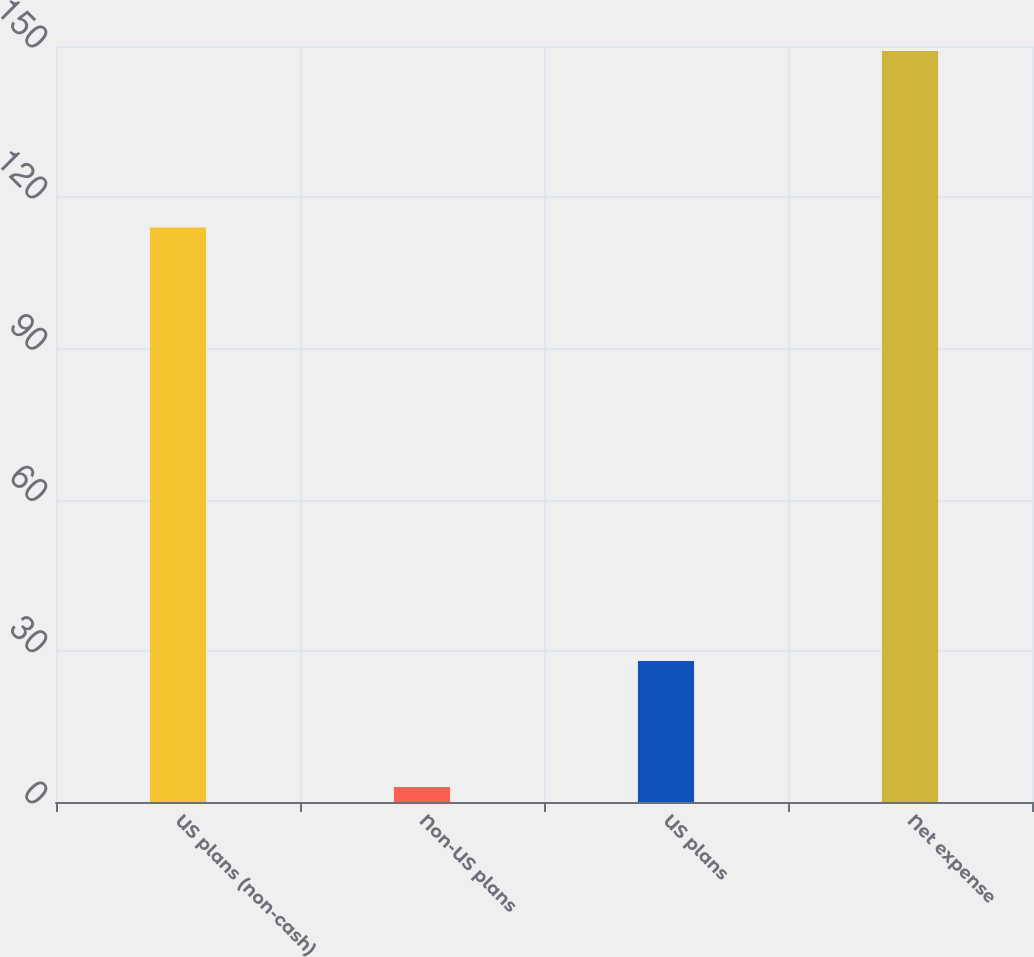Convert chart to OTSL. <chart><loc_0><loc_0><loc_500><loc_500><bar_chart><fcel>US plans (non-cash)<fcel>Non-US plans<fcel>US plans<fcel>Net expense<nl><fcel>114<fcel>3<fcel>28<fcel>149<nl></chart> 